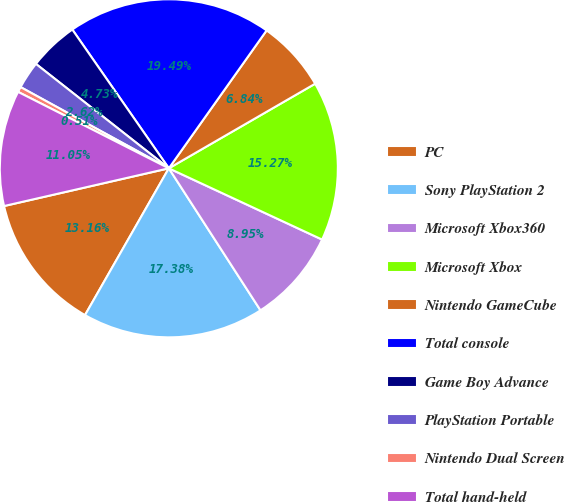Convert chart. <chart><loc_0><loc_0><loc_500><loc_500><pie_chart><fcel>PC<fcel>Sony PlayStation 2<fcel>Microsoft Xbox360<fcel>Microsoft Xbox<fcel>Nintendo GameCube<fcel>Total console<fcel>Game Boy Advance<fcel>PlayStation Portable<fcel>Nintendo Dual Screen<fcel>Total hand-held<nl><fcel>13.16%<fcel>17.38%<fcel>8.95%<fcel>15.27%<fcel>6.84%<fcel>19.49%<fcel>4.73%<fcel>2.62%<fcel>0.51%<fcel>11.05%<nl></chart> 